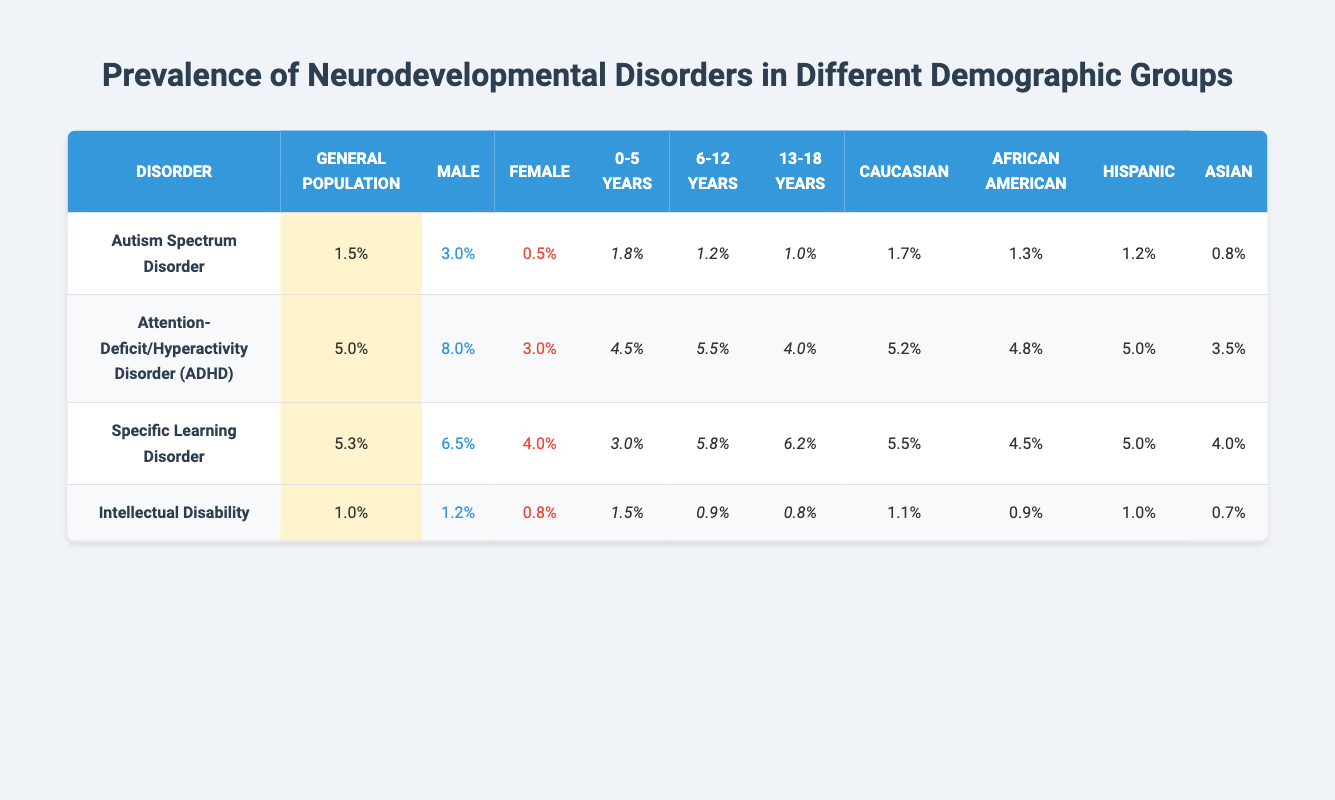What is the prevalence of Autism Spectrum Disorder in the general population? Referring to the table, the prevalence of Autism Spectrum Disorder in the general population is listed as 1.5%.
Answer: 1.5% Which gender has a higher prevalence of Attention-Deficit/Hyperactivity Disorder? The table shows that the prevalence of ADHD is 8.0% in males and 3.0% in females; thus, males have a higher prevalence.
Answer: Males What is the prevalence of Specific Learning Disorder in the age group 6-12 years? Looking at the age group column for Specific Learning Disorder, the prevalence in the 6-12 years age group is 5.8%.
Answer: 5.8% Is the prevalence of Intellectual Disability higher in males or females? By checking the values, males have a prevalence of 1.2% while females have 0.8%, indicating that Intellectual Disability is higher in males.
Answer: Males What is the difference in prevalence of Autism Spectrum Disorder between males and females? The prevalence for males is 3.0% and for females is 0.5%. The difference is 3.0% - 0.5% = 2.5%.
Answer: 2.5% What is the average prevalence of neurodevelopmental disorders in the Caucasian ethnicity category? The prevalent values for Caucasian are 1.7% (Autism), 5.2% (ADHD), 5.5% (Specific Learning Disorder), and 1.1% (Intellectual Disability), so the average is (1.7 + 5.2 + 5.5 + 1.1) / 4 = 3.375%.
Answer: 3.375% Is the prevalence of ADHD among African Americans higher or lower than the prevalence among Asians? The prevalence of ADHD among African Americans is 4.8% while it is 3.5% among Asians, indicating it is higher among African Americans.
Answer: Higher Which age group has the highest prevalence of Specific Learning Disorder? The age group for Specific Learning Disorder yields 3.0% for 0-5 years, 5.8% for 6-12 years, and 6.2% for 13-18 years; thus, the highest prevalence is in the 13-18 years age group.
Answer: 13-18 years What is the prevalence of neurodevelopmental disorders in females compared to males across all disorders listed? By looking through the female prevalence values (0.5%, 3.0%, 4.0%, 0.8%) and male values (3.0%, 8.0%, 6.5%, 1.2%), we can compare the averages: average for females: (0.5 + 3.0 + 4.0 + 0.8) / 4 = 2.083% and for males: (3.0 + 8.0 + 6.5 + 1.2) / 4 = 4.425%. Thus, males have a higher average prevalence.
Answer: Males What is the trend in prevalence of Autism Spectrum Disorder as age increases? The table indicates that the prevalence in the age groups decreases with age: 1.8% (0-5 years), 1.2% (6-12 years), and 1.0% (13-18 years), suggesting a downward trend.
Answer: Decreases 